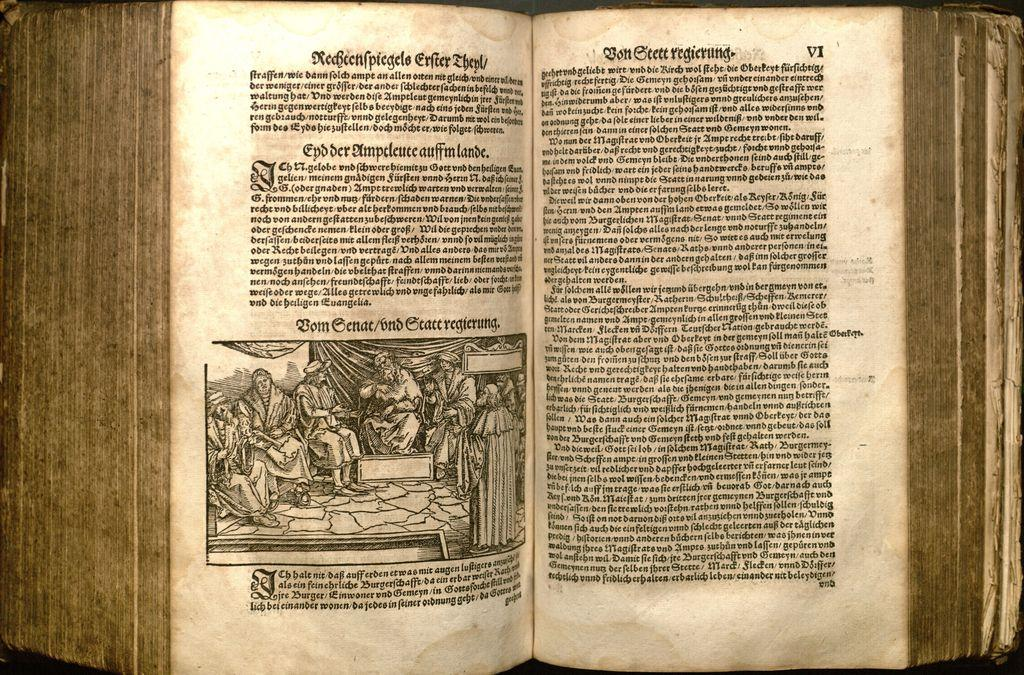<image>
Offer a succinct explanation of the picture presented. an open book open to page vi with bold lettering on it 